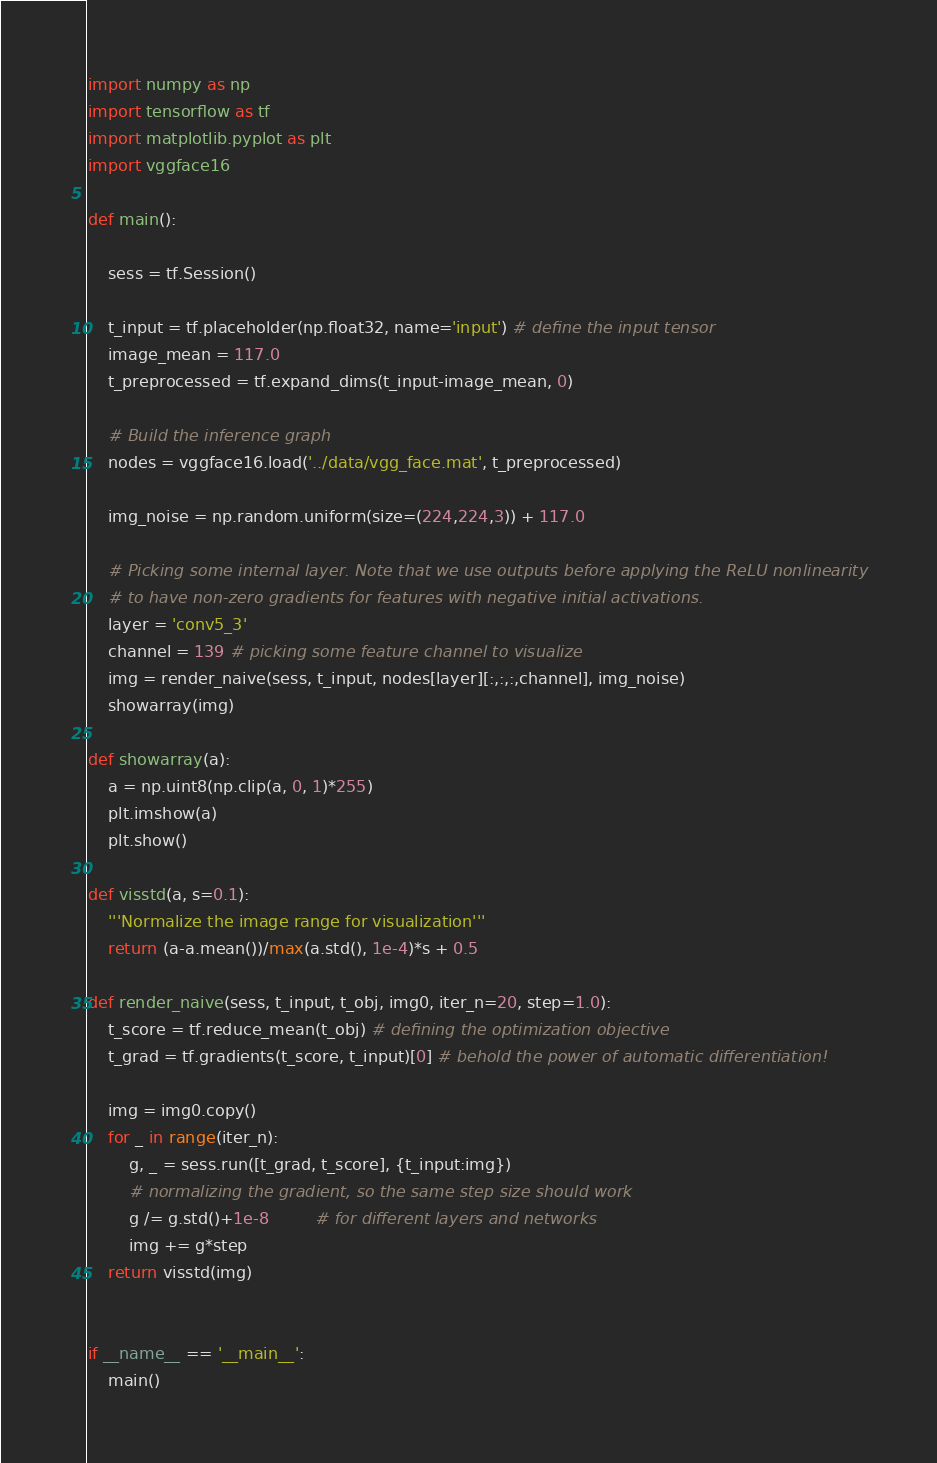Convert code to text. <code><loc_0><loc_0><loc_500><loc_500><_Python_>import numpy as np
import tensorflow as tf
import matplotlib.pyplot as plt
import vggface16

def main():
  
    sess = tf.Session()
  
    t_input = tf.placeholder(np.float32, name='input') # define the input tensor
    image_mean = 117.0
    t_preprocessed = tf.expand_dims(t_input-image_mean, 0)
     
    # Build the inference graph
    nodes = vggface16.load('../data/vgg_face.mat', t_preprocessed)
        
    img_noise = np.random.uniform(size=(224,224,3)) + 117.0

    # Picking some internal layer. Note that we use outputs before applying the ReLU nonlinearity
    # to have non-zero gradients for features with negative initial activations.
    layer = 'conv5_3'
    channel = 139 # picking some feature channel to visualize
    img = render_naive(sess, t_input, nodes[layer][:,:,:,channel], img_noise)
    showarray(img)

def showarray(a):
    a = np.uint8(np.clip(a, 0, 1)*255)
    plt.imshow(a)
    plt.show()
    
def visstd(a, s=0.1):
    '''Normalize the image range for visualization'''
    return (a-a.mean())/max(a.std(), 1e-4)*s + 0.5

def render_naive(sess, t_input, t_obj, img0, iter_n=20, step=1.0):
    t_score = tf.reduce_mean(t_obj) # defining the optimization objective
    t_grad = tf.gradients(t_score, t_input)[0] # behold the power of automatic differentiation!
    
    img = img0.copy()
    for _ in range(iter_n):
        g, _ = sess.run([t_grad, t_score], {t_input:img})
        # normalizing the gradient, so the same step size should work 
        g /= g.std()+1e-8         # for different layers and networks
        img += g*step
    return visstd(img)

  
if __name__ == '__main__':
    main()
</code> 